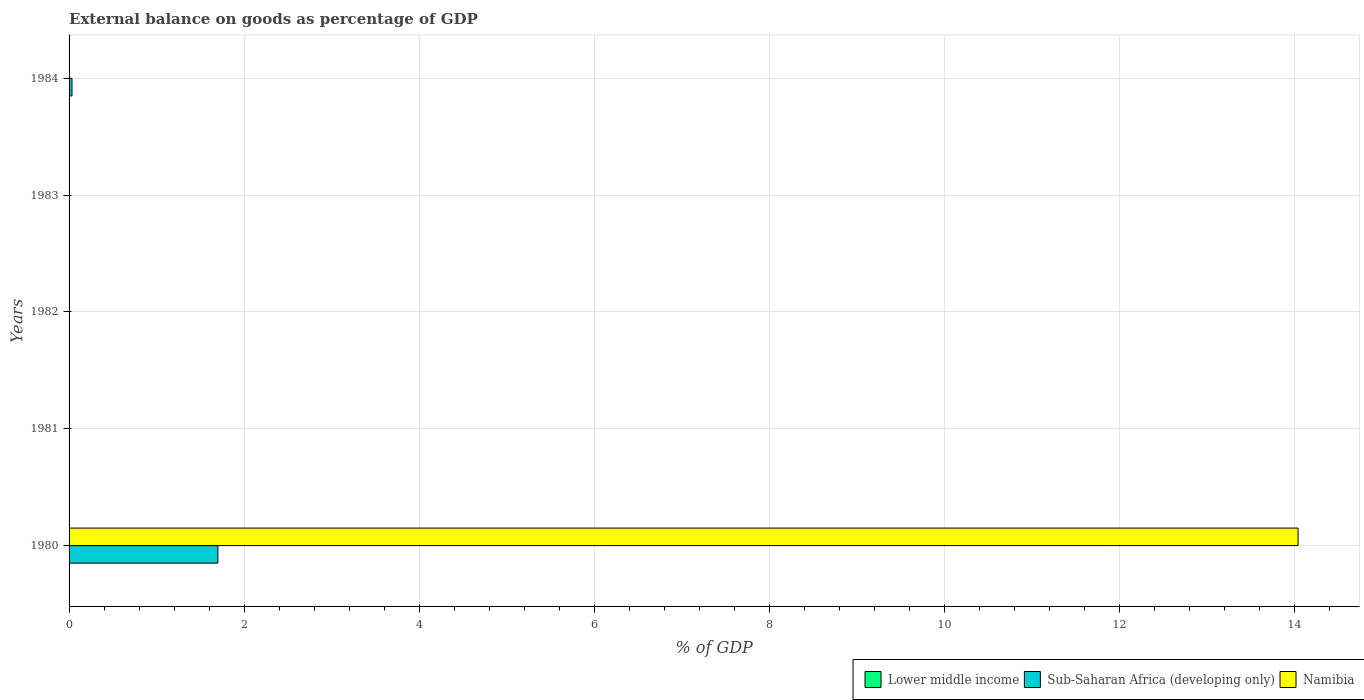How many different coloured bars are there?
Give a very brief answer. 2. Are the number of bars per tick equal to the number of legend labels?
Offer a very short reply. No. How many bars are there on the 1st tick from the top?
Your response must be concise. 1. How many bars are there on the 4th tick from the bottom?
Your answer should be compact. 0. What is the external balance on goods as percentage of GDP in Lower middle income in 1983?
Your response must be concise. 0. Across all years, what is the maximum external balance on goods as percentage of GDP in Sub-Saharan Africa (developing only)?
Keep it short and to the point. 1.7. Across all years, what is the minimum external balance on goods as percentage of GDP in Namibia?
Your response must be concise. 0. In which year was the external balance on goods as percentage of GDP in Namibia maximum?
Your answer should be compact. 1980. What is the total external balance on goods as percentage of GDP in Namibia in the graph?
Your answer should be compact. 14.04. What is the average external balance on goods as percentage of GDP in Sub-Saharan Africa (developing only) per year?
Give a very brief answer. 0.35. In the year 1980, what is the difference between the external balance on goods as percentage of GDP in Sub-Saharan Africa (developing only) and external balance on goods as percentage of GDP in Namibia?
Offer a terse response. -12.34. In how many years, is the external balance on goods as percentage of GDP in Namibia greater than 12.8 %?
Ensure brevity in your answer.  1. What is the difference between the highest and the lowest external balance on goods as percentage of GDP in Namibia?
Offer a very short reply. 14.04. Is it the case that in every year, the sum of the external balance on goods as percentage of GDP in Sub-Saharan Africa (developing only) and external balance on goods as percentage of GDP in Namibia is greater than the external balance on goods as percentage of GDP in Lower middle income?
Your response must be concise. No. How many bars are there?
Make the answer very short. 3. Are all the bars in the graph horizontal?
Your response must be concise. Yes. Does the graph contain any zero values?
Your answer should be compact. Yes. How many legend labels are there?
Your answer should be compact. 3. What is the title of the graph?
Offer a terse response. External balance on goods as percentage of GDP. What is the label or title of the X-axis?
Provide a short and direct response. % of GDP. What is the % of GDP of Sub-Saharan Africa (developing only) in 1980?
Your answer should be very brief. 1.7. What is the % of GDP in Namibia in 1980?
Your answer should be very brief. 14.04. What is the % of GDP in Sub-Saharan Africa (developing only) in 1982?
Your answer should be compact. 0. What is the % of GDP of Namibia in 1982?
Keep it short and to the point. 0. What is the % of GDP in Lower middle income in 1983?
Offer a very short reply. 0. What is the % of GDP of Sub-Saharan Africa (developing only) in 1984?
Your answer should be compact. 0.03. Across all years, what is the maximum % of GDP of Sub-Saharan Africa (developing only)?
Your response must be concise. 1.7. Across all years, what is the maximum % of GDP of Namibia?
Provide a short and direct response. 14.04. Across all years, what is the minimum % of GDP of Sub-Saharan Africa (developing only)?
Ensure brevity in your answer.  0. Across all years, what is the minimum % of GDP in Namibia?
Keep it short and to the point. 0. What is the total % of GDP of Sub-Saharan Africa (developing only) in the graph?
Your response must be concise. 1.73. What is the total % of GDP in Namibia in the graph?
Ensure brevity in your answer.  14.04. What is the average % of GDP in Lower middle income per year?
Your answer should be very brief. 0. What is the average % of GDP of Sub-Saharan Africa (developing only) per year?
Offer a terse response. 0.35. What is the average % of GDP of Namibia per year?
Provide a short and direct response. 2.81. In the year 1980, what is the difference between the % of GDP of Sub-Saharan Africa (developing only) and % of GDP of Namibia?
Give a very brief answer. -12.34. What is the ratio of the % of GDP in Sub-Saharan Africa (developing only) in 1980 to that in 1984?
Your answer should be compact. 51.16. What is the difference between the highest and the lowest % of GDP of Sub-Saharan Africa (developing only)?
Give a very brief answer. 1.7. What is the difference between the highest and the lowest % of GDP of Namibia?
Keep it short and to the point. 14.04. 